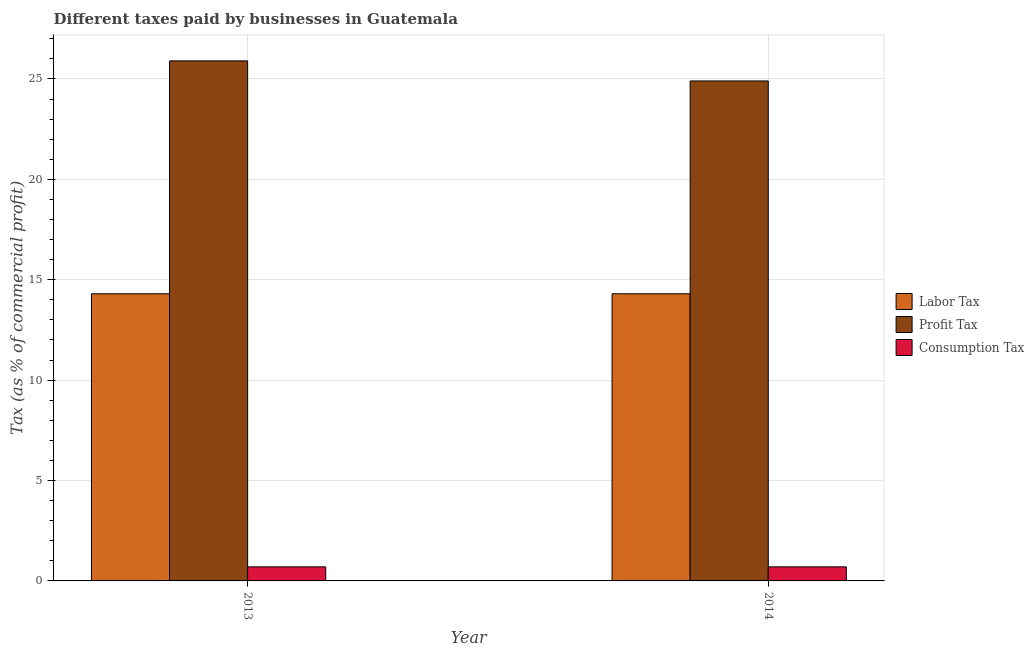How many different coloured bars are there?
Your response must be concise. 3. Are the number of bars on each tick of the X-axis equal?
Your response must be concise. Yes. How many bars are there on the 2nd tick from the right?
Give a very brief answer. 3. What is the label of the 2nd group of bars from the left?
Your response must be concise. 2014. In how many cases, is the number of bars for a given year not equal to the number of legend labels?
Your answer should be very brief. 0. What is the percentage of labor tax in 2014?
Your answer should be very brief. 14.3. Across all years, what is the maximum percentage of consumption tax?
Your answer should be very brief. 0.7. Across all years, what is the minimum percentage of profit tax?
Give a very brief answer. 24.9. In which year was the percentage of labor tax minimum?
Your answer should be compact. 2013. What is the difference between the percentage of consumption tax in 2013 and that in 2014?
Ensure brevity in your answer.  0. What is the average percentage of labor tax per year?
Your response must be concise. 14.3. In how many years, is the percentage of labor tax greater than 8 %?
Your answer should be very brief. 2. Is the percentage of labor tax in 2013 less than that in 2014?
Offer a very short reply. No. What does the 3rd bar from the left in 2014 represents?
Provide a succinct answer. Consumption Tax. What does the 2nd bar from the right in 2014 represents?
Keep it short and to the point. Profit Tax. Is it the case that in every year, the sum of the percentage of labor tax and percentage of profit tax is greater than the percentage of consumption tax?
Offer a terse response. Yes. Are all the bars in the graph horizontal?
Your response must be concise. No. Are the values on the major ticks of Y-axis written in scientific E-notation?
Provide a succinct answer. No. Does the graph contain grids?
Offer a terse response. Yes. Where does the legend appear in the graph?
Your answer should be very brief. Center right. How many legend labels are there?
Offer a terse response. 3. What is the title of the graph?
Offer a terse response. Different taxes paid by businesses in Guatemala. What is the label or title of the X-axis?
Your response must be concise. Year. What is the label or title of the Y-axis?
Make the answer very short. Tax (as % of commercial profit). What is the Tax (as % of commercial profit) of Labor Tax in 2013?
Keep it short and to the point. 14.3. What is the Tax (as % of commercial profit) in Profit Tax in 2013?
Provide a succinct answer. 25.9. What is the Tax (as % of commercial profit) of Profit Tax in 2014?
Ensure brevity in your answer.  24.9. What is the Tax (as % of commercial profit) in Consumption Tax in 2014?
Offer a very short reply. 0.7. Across all years, what is the maximum Tax (as % of commercial profit) in Labor Tax?
Provide a short and direct response. 14.3. Across all years, what is the maximum Tax (as % of commercial profit) of Profit Tax?
Provide a succinct answer. 25.9. Across all years, what is the maximum Tax (as % of commercial profit) of Consumption Tax?
Ensure brevity in your answer.  0.7. Across all years, what is the minimum Tax (as % of commercial profit) in Labor Tax?
Offer a terse response. 14.3. Across all years, what is the minimum Tax (as % of commercial profit) in Profit Tax?
Your answer should be very brief. 24.9. What is the total Tax (as % of commercial profit) of Labor Tax in the graph?
Offer a very short reply. 28.6. What is the total Tax (as % of commercial profit) in Profit Tax in the graph?
Your answer should be very brief. 50.8. What is the difference between the Tax (as % of commercial profit) of Consumption Tax in 2013 and that in 2014?
Your answer should be very brief. 0. What is the difference between the Tax (as % of commercial profit) in Profit Tax in 2013 and the Tax (as % of commercial profit) in Consumption Tax in 2014?
Give a very brief answer. 25.2. What is the average Tax (as % of commercial profit) of Profit Tax per year?
Offer a terse response. 25.4. In the year 2013, what is the difference between the Tax (as % of commercial profit) in Profit Tax and Tax (as % of commercial profit) in Consumption Tax?
Provide a succinct answer. 25.2. In the year 2014, what is the difference between the Tax (as % of commercial profit) in Profit Tax and Tax (as % of commercial profit) in Consumption Tax?
Offer a terse response. 24.2. What is the ratio of the Tax (as % of commercial profit) in Labor Tax in 2013 to that in 2014?
Your response must be concise. 1. What is the ratio of the Tax (as % of commercial profit) in Profit Tax in 2013 to that in 2014?
Provide a short and direct response. 1.04. What is the ratio of the Tax (as % of commercial profit) of Consumption Tax in 2013 to that in 2014?
Give a very brief answer. 1. What is the difference between the highest and the second highest Tax (as % of commercial profit) of Labor Tax?
Provide a succinct answer. 0. What is the difference between the highest and the second highest Tax (as % of commercial profit) of Consumption Tax?
Your response must be concise. 0. What is the difference between the highest and the lowest Tax (as % of commercial profit) of Labor Tax?
Provide a short and direct response. 0. What is the difference between the highest and the lowest Tax (as % of commercial profit) of Consumption Tax?
Ensure brevity in your answer.  0. 